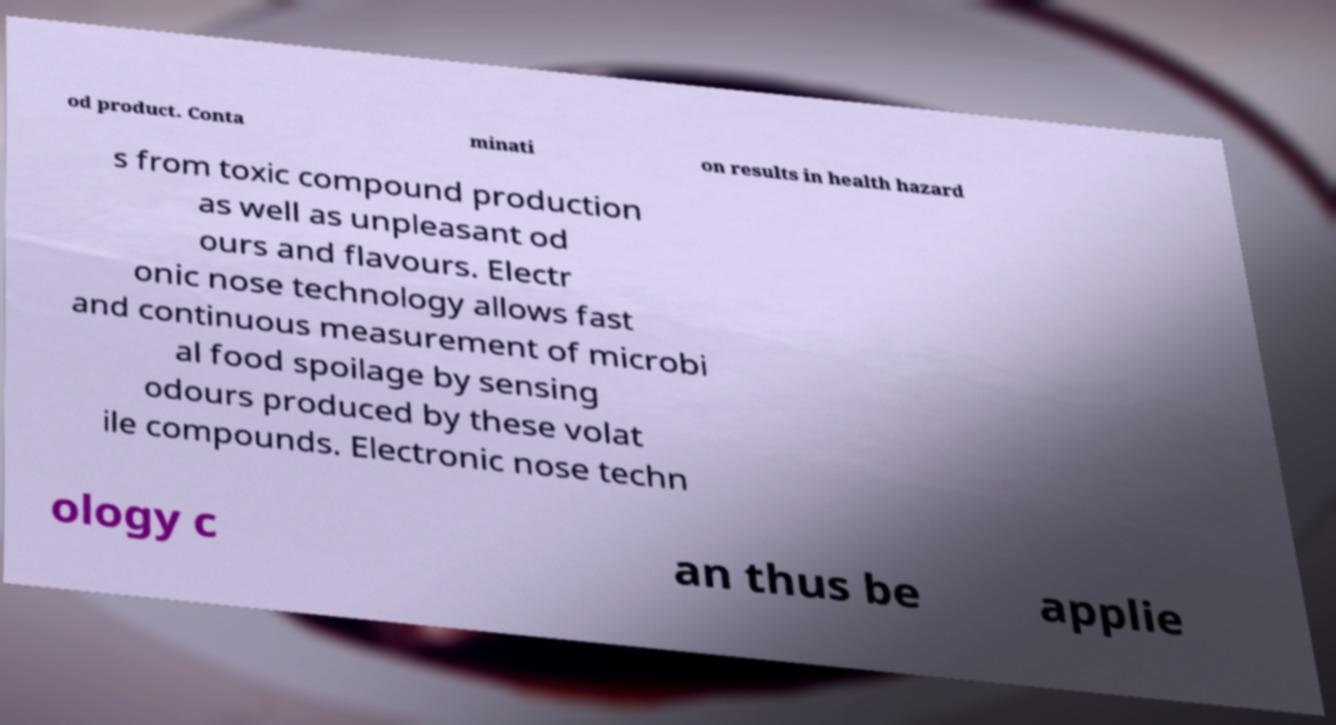Could you extract and type out the text from this image? od product. Conta minati on results in health hazard s from toxic compound production as well as unpleasant od ours and flavours. Electr onic nose technology allows fast and continuous measurement of microbi al food spoilage by sensing odours produced by these volat ile compounds. Electronic nose techn ology c an thus be applie 